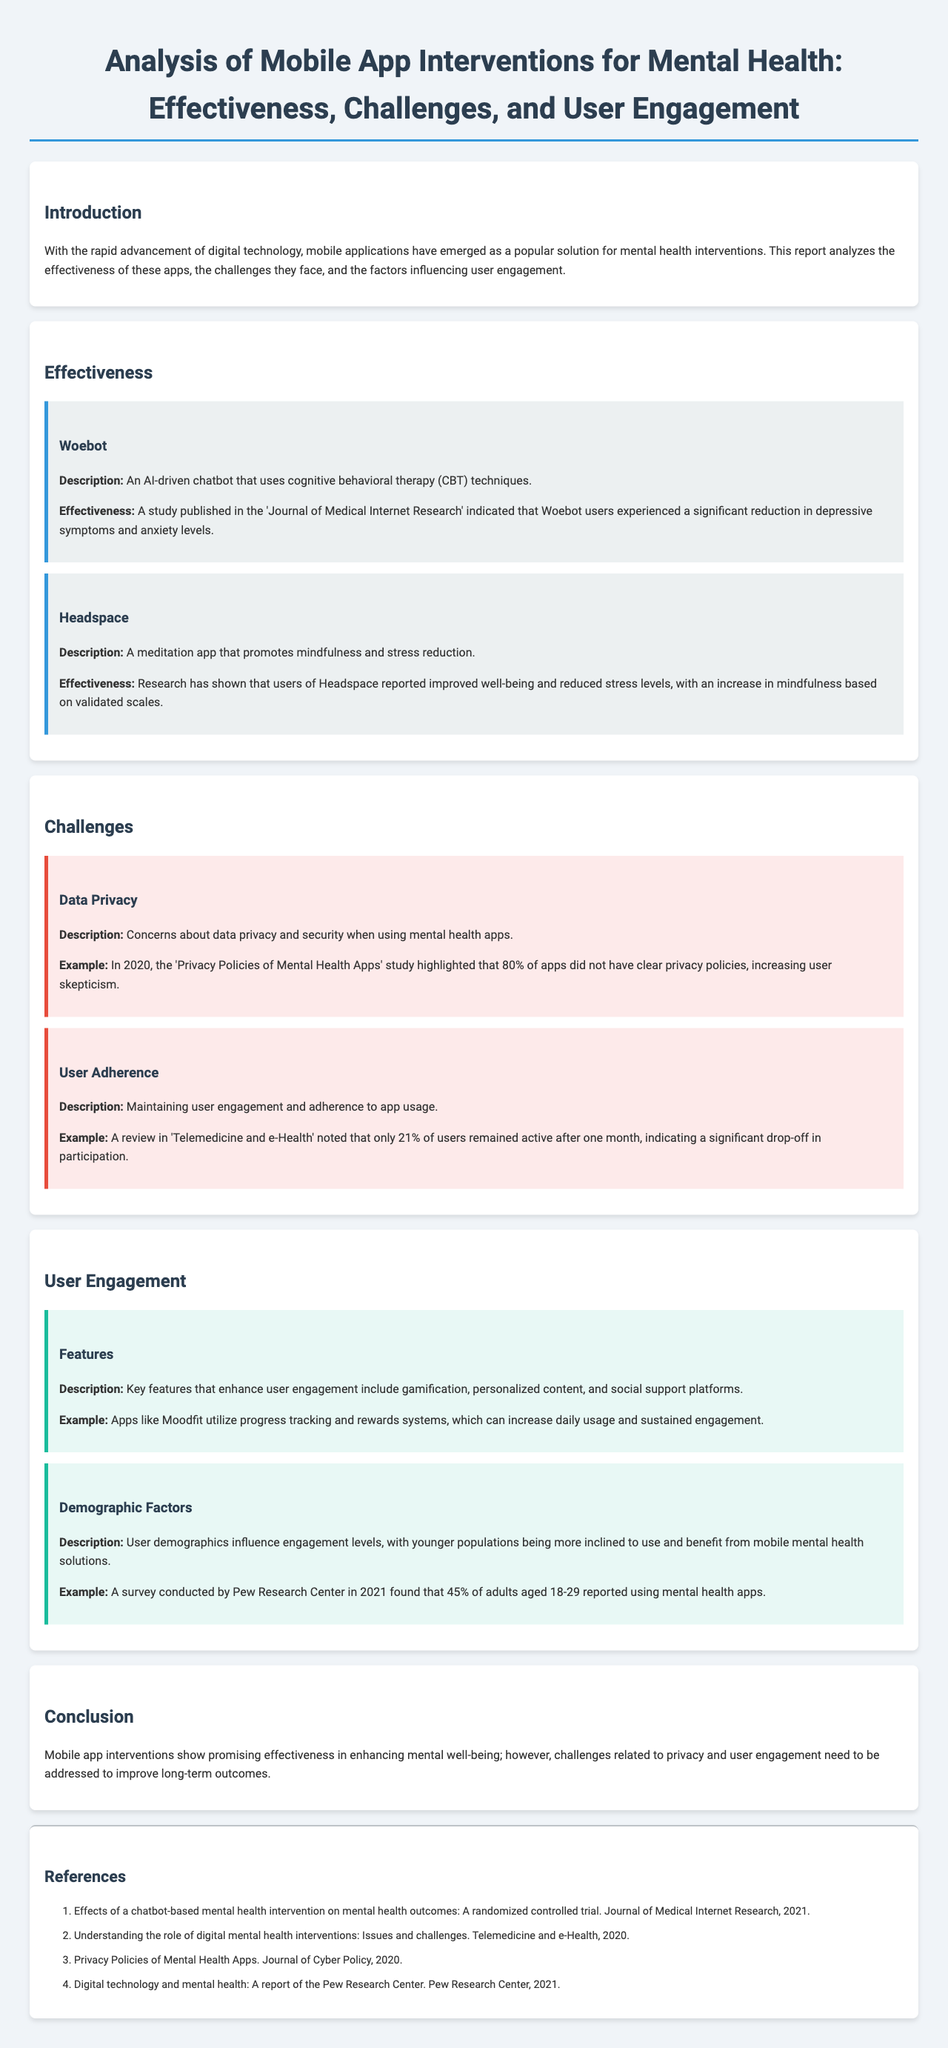What is the name of the AI-driven chatbot mentioned? The document describes an AI-driven chatbot that uses cognitive behavioral therapy techniques, named Woebot.
Answer: Woebot What percentage of users remained active after one month? A review noted that only 21% of users remained active after one month, indicating a significant drop-off in participation.
Answer: 21% What type of app is Headspace? Headspace is described as a meditation app that promotes mindfulness and stress reduction.
Answer: Meditation What is a key user engagement feature mentioned in the report? The report highlights that key features enhancing user engagement include gamification, personalized content, and social support platforms.
Answer: Gamification What major concern about mobile apps was highlighted in 2020? The document mentions concerns about data privacy and security when using mental health apps as a major challenge, citing a study indicating a lack of clear privacy policies.
Answer: Data Privacy Which demographic is reported to be more inclined to use mental health apps? The document states that younger populations are more inclined to use and benefit from mobile mental health solutions.
Answer: Younger populations What publication reported the effectiveness of Woebot? The effectiveness of Woebot is indicated to have been published in the Journal of Medical Internet Research.
Answer: Journal of Medical Internet Research What was the outcome of using Headspace according to research? Research indicated that users of Headspace reported improved well-being and reduced stress levels.
Answer: Improved well-being What unresolved issue does the conclusion mention? The conclusion emphasizes that challenges related to privacy and user engagement still need to be addressed to improve long-term outcomes.
Answer: Privacy and user engagement 